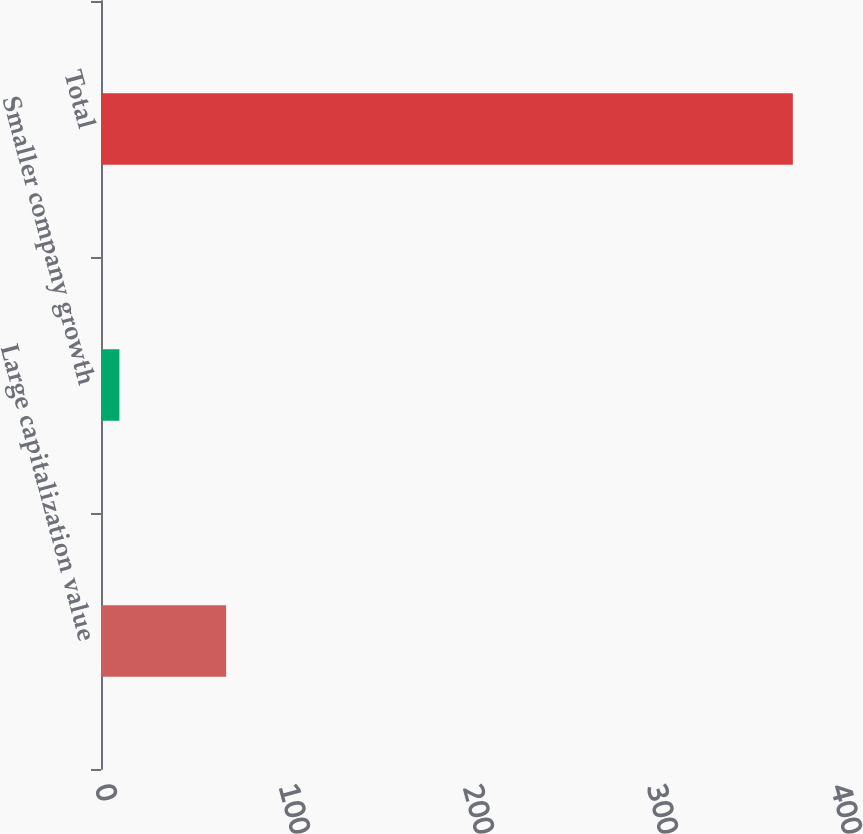Convert chart. <chart><loc_0><loc_0><loc_500><loc_500><bar_chart><fcel>Large capitalization value<fcel>Smaller company growth<fcel>Total<nl><fcel>68<fcel>10<fcel>376<nl></chart> 